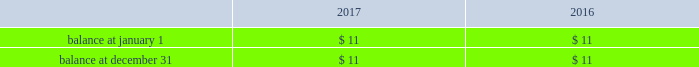Host hotels & resorts , inc. , host hotels & resorts , l.p. , and subsidiaries notes to consolidated financial statements 2014 ( continued ) cash paid for income taxes , net of refunds received , was $ 40 million , $ 15 million , and $ 9 million in 2017 , 2016 , and 2015 , respectively .
A reconciliation of the beginning and ending amount of unrecognized tax benefits is as follows ( in millions ) : .
All of such uncertain tax position amounts , if recognized , would impact our reconciliation between the income tax provision calculated at the statutory u.s .
Federal income tax rate of 35% ( 35 % ) ( 21% ( 21 % ) beginning with calendar year 2018 ) and the actual income tax provision recorded each year .
As of december 31 , 2017 , the tax years that remain subject to examination by major tax jurisdictions generally include 2014-2017 .
There were no material interest or penalties recorded for the years ended december 31 , 2017 , 2016 , and 2015 .
Leases taxable reit subsidiaries leases we lease substantially all of our hotels to a wholly owned subsidiary that qualifies as a taxable reit subsidiary due to federal income tax restrictions on a reit 2019s ability to derive revenue directly from the operation and management of a hotel .
Ground leases as of december 31 , 2017 , all or a portion of 26 of our hotels are subject to ground leases , generally with multiple renewal options , all of which are accounted for as operating leases .
For lease agreements with scheduled rent increases , we recognize the lease expense ratably over the term of the lease .
Certain of these leases contain provisions for the payment of contingent rentals based on a percentage of sales in excess of stipulated amounts .
Other lease information we also have leases on facilities used in our former restaurant business , all of which we subsequently subleased .
These leases and subleases contain one or more renewal options , generally for five- or ten-year periods .
The restaurant leases are accounted for as operating leases .
Our contingent liability related to these leases is $ 9 million as of december 31 , 2017 .
We , however , consider the likelihood of any material funding related to these leases to be remote .
Our leasing activity also includes those entered into by our hotels for various types of equipment , such as computer equipment , vehicles and telephone systems .
Equipment leases are accounted for either as operating or capital leases , depending upon the characteristics of the particular lease arrangement .
Equipment leases that are characterized as capital leases are classified as furniture and equipment and are depreciated over the life of the lease .
The amortization expense applicable to capitalized leases is included in depreciation expense. .
What was the percentage change in cash paid for income taxes , net of refunds received between 2015 and 2016? 
Computations: ((15 - 9) / 9)
Answer: 0.66667. 